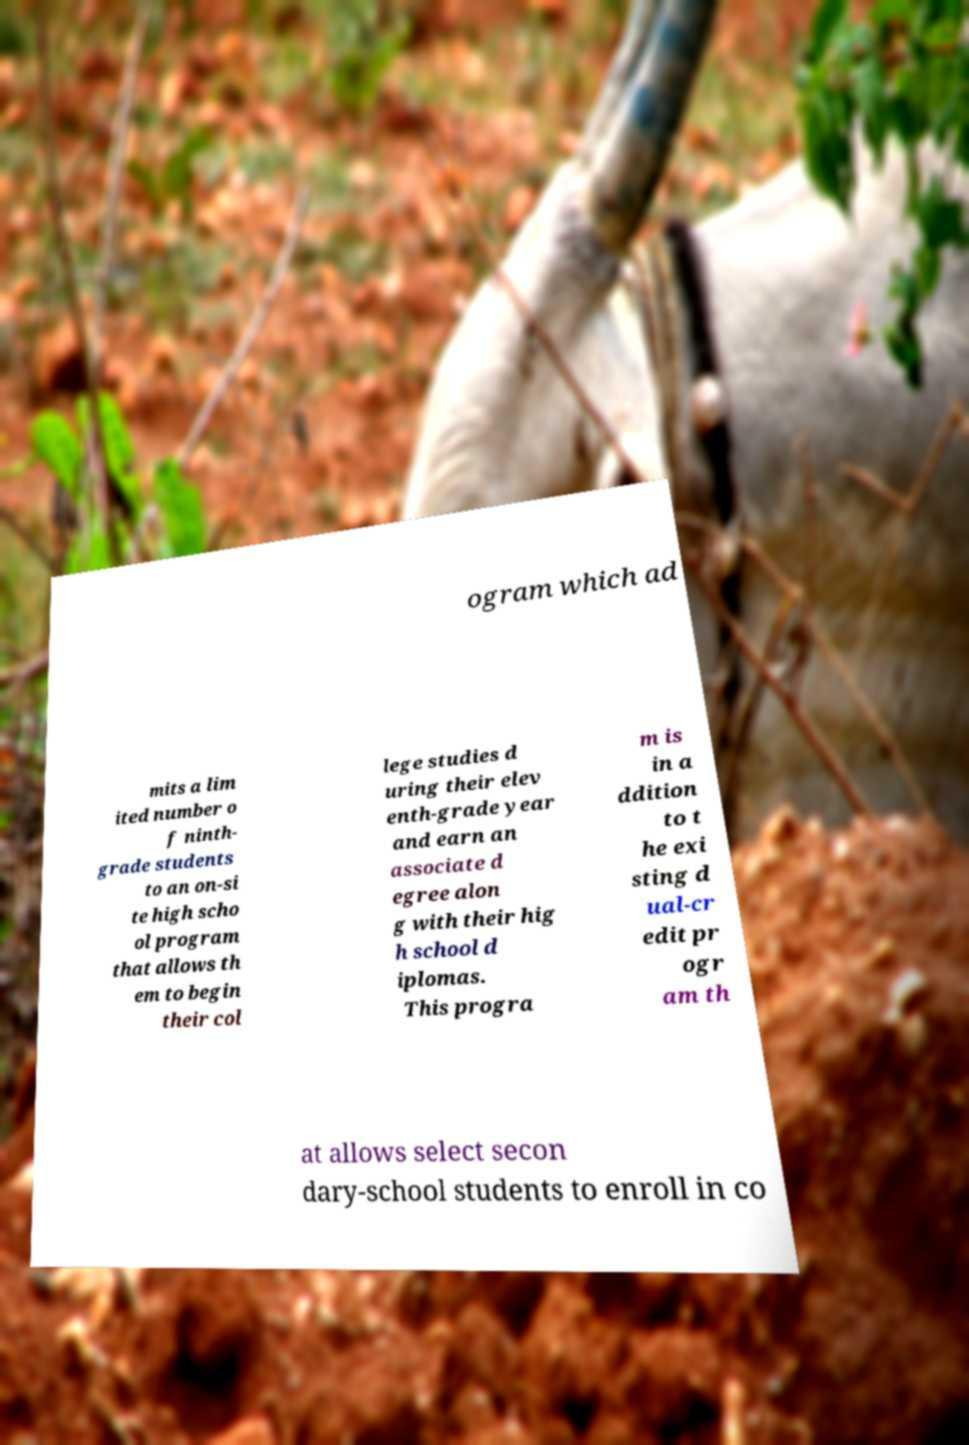What messages or text are displayed in this image? I need them in a readable, typed format. ogram which ad mits a lim ited number o f ninth- grade students to an on-si te high scho ol program that allows th em to begin their col lege studies d uring their elev enth-grade year and earn an associate d egree alon g with their hig h school d iplomas. This progra m is in a ddition to t he exi sting d ual-cr edit pr ogr am th at allows select secon dary-school students to enroll in co 